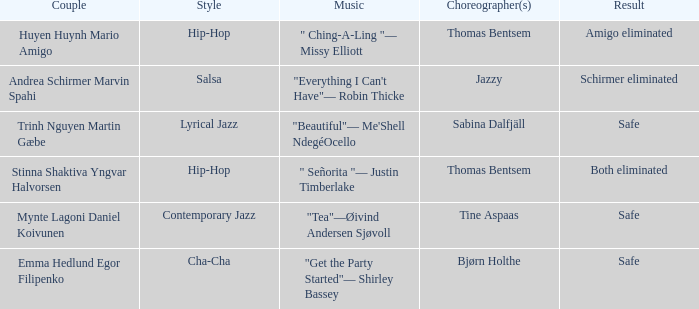What couple had a safe result and a lyrical jazz style? Trinh Nguyen Martin Gæbe. 